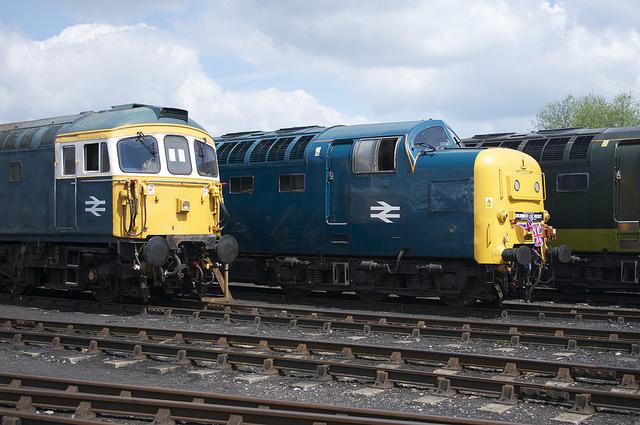What is hanging on the front of the middle train?
Quick response, please. Flag. How many trains are visible?
Concise answer only. 3. Do the trains look exactly alike?
Concise answer only. No. 